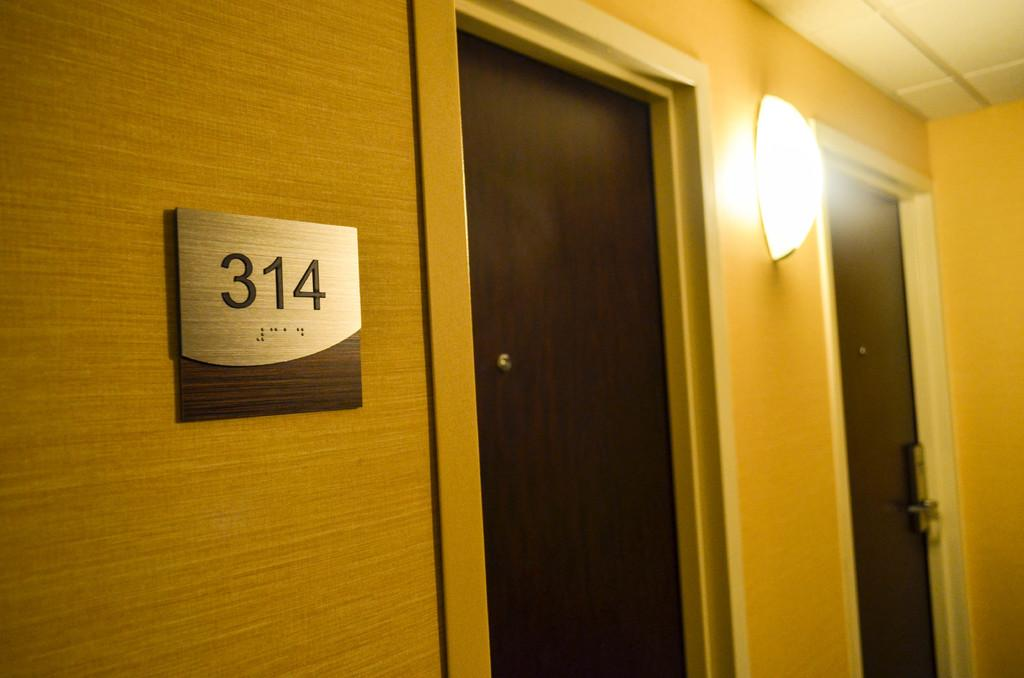What can be seen on the left side of the image? There is a number board and a light attached to the wall on the left side of the image. How many doors are visible in the image? There are two doors in the image. What is located on the right side of the image? There is a roof and a wall on the right side of the image. How many babies are attempting to climb the wall in the image? There are no babies present in the image, and therefore no such activity can be observed. What angle is the roof at in the image? The angle of the roof cannot be determined from the image, as it is not depicted in a way that allows for the measurement of angles. 